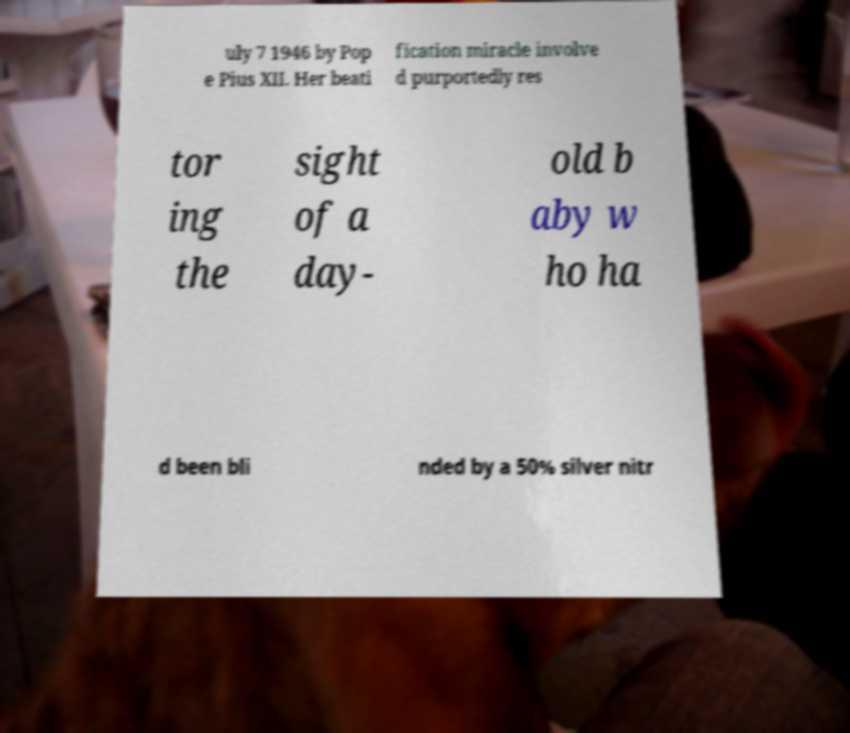Could you assist in decoding the text presented in this image and type it out clearly? uly 7 1946 by Pop e Pius XII. Her beati fication miracle involve d purportedly res tor ing the sight of a day- old b aby w ho ha d been bli nded by a 50% silver nitr 